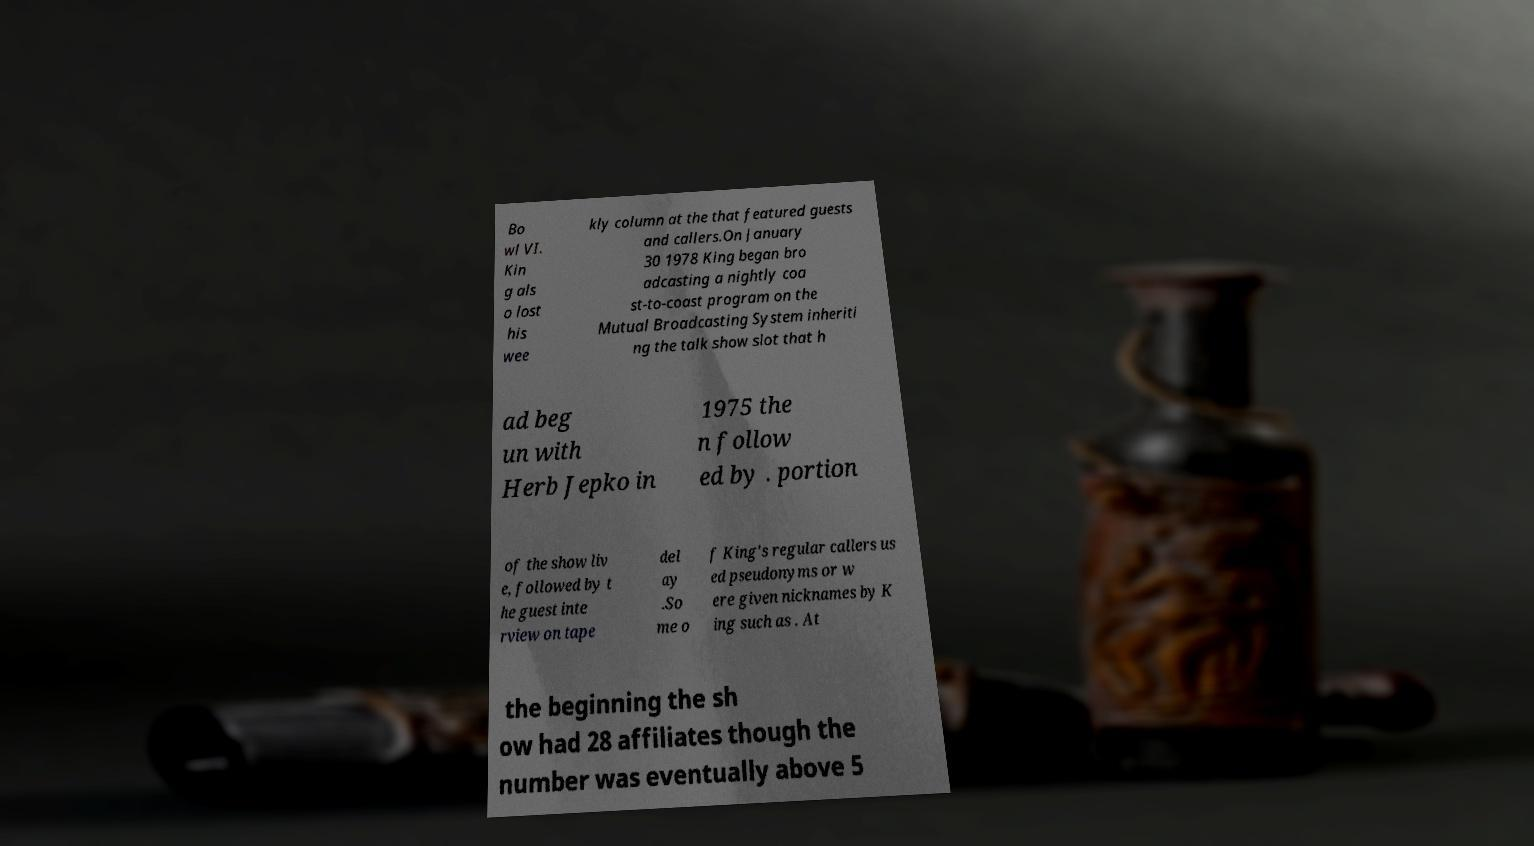Can you read and provide the text displayed in the image?This photo seems to have some interesting text. Can you extract and type it out for me? Bo wl VI. Kin g als o lost his wee kly column at the that featured guests and callers.On January 30 1978 King began bro adcasting a nightly coa st-to-coast program on the Mutual Broadcasting System inheriti ng the talk show slot that h ad beg un with Herb Jepko in 1975 the n follow ed by . portion of the show liv e, followed by t he guest inte rview on tape del ay .So me o f King's regular callers us ed pseudonyms or w ere given nicknames by K ing such as . At the beginning the sh ow had 28 affiliates though the number was eventually above 5 